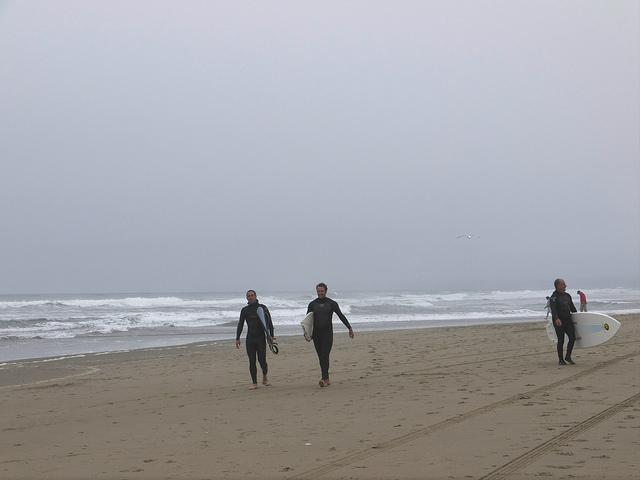The lines on the sand were made by what part of a vehicle? tires 